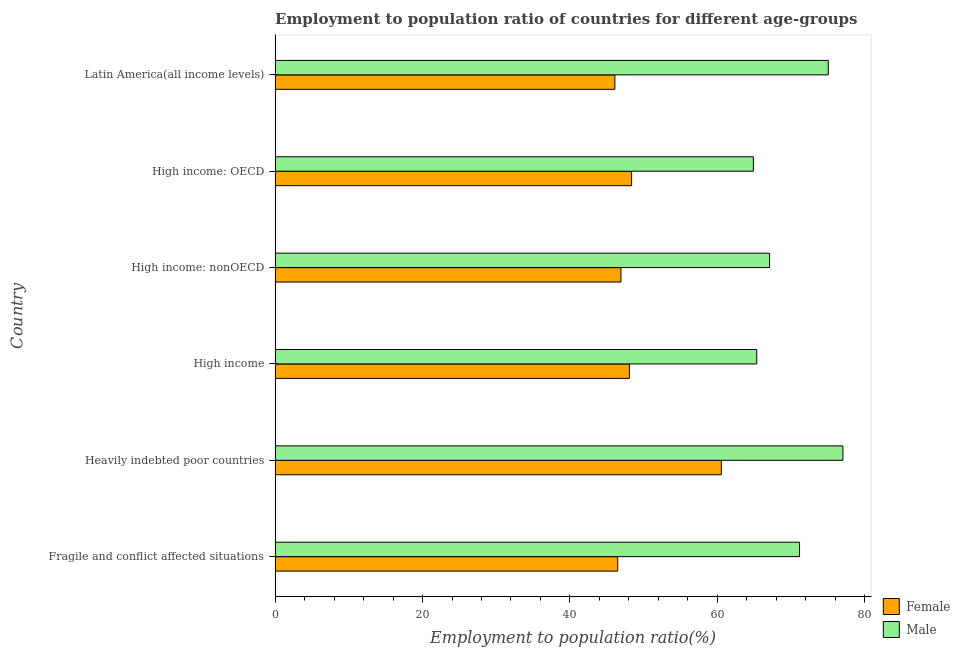How many different coloured bars are there?
Your answer should be very brief. 2. How many groups of bars are there?
Offer a very short reply. 6. Are the number of bars per tick equal to the number of legend labels?
Ensure brevity in your answer.  Yes. Are the number of bars on each tick of the Y-axis equal?
Make the answer very short. Yes. How many bars are there on the 4th tick from the top?
Provide a short and direct response. 2. What is the label of the 5th group of bars from the top?
Offer a terse response. Heavily indebted poor countries. What is the employment to population ratio(male) in Heavily indebted poor countries?
Your answer should be very brief. 77.03. Across all countries, what is the maximum employment to population ratio(female)?
Keep it short and to the point. 60.54. Across all countries, what is the minimum employment to population ratio(male)?
Keep it short and to the point. 64.89. In which country was the employment to population ratio(female) maximum?
Your answer should be compact. Heavily indebted poor countries. In which country was the employment to population ratio(male) minimum?
Your response must be concise. High income: OECD. What is the total employment to population ratio(female) in the graph?
Offer a very short reply. 296.46. What is the difference between the employment to population ratio(male) in High income and that in High income: OECD?
Your response must be concise. 0.45. What is the difference between the employment to population ratio(female) in High income and the employment to population ratio(male) in Latin America(all income levels)?
Offer a very short reply. -26.98. What is the average employment to population ratio(male) per country?
Your answer should be compact. 70.09. What is the difference between the employment to population ratio(male) and employment to population ratio(female) in Heavily indebted poor countries?
Keep it short and to the point. 16.49. What is the ratio of the employment to population ratio(male) in Fragile and conflict affected situations to that in High income: nonOECD?
Make the answer very short. 1.06. What is the difference between the highest and the second highest employment to population ratio(female)?
Ensure brevity in your answer.  12.17. What is the difference between the highest and the lowest employment to population ratio(female)?
Offer a terse response. 14.44. In how many countries, is the employment to population ratio(female) greater than the average employment to population ratio(female) taken over all countries?
Provide a succinct answer. 1. Is the sum of the employment to population ratio(male) in Fragile and conflict affected situations and Heavily indebted poor countries greater than the maximum employment to population ratio(female) across all countries?
Your response must be concise. Yes. What does the 1st bar from the top in Fragile and conflict affected situations represents?
Your answer should be compact. Male. How many bars are there?
Ensure brevity in your answer.  12. How many countries are there in the graph?
Ensure brevity in your answer.  6. What is the difference between two consecutive major ticks on the X-axis?
Make the answer very short. 20. Are the values on the major ticks of X-axis written in scientific E-notation?
Keep it short and to the point. No. Does the graph contain grids?
Your answer should be compact. No. Where does the legend appear in the graph?
Keep it short and to the point. Bottom right. How are the legend labels stacked?
Your answer should be very brief. Vertical. What is the title of the graph?
Keep it short and to the point. Employment to population ratio of countries for different age-groups. Does "Age 15+" appear as one of the legend labels in the graph?
Your answer should be very brief. No. What is the label or title of the X-axis?
Your answer should be very brief. Employment to population ratio(%). What is the label or title of the Y-axis?
Give a very brief answer. Country. What is the Employment to population ratio(%) in Female in Fragile and conflict affected situations?
Make the answer very short. 46.48. What is the Employment to population ratio(%) of Male in Fragile and conflict affected situations?
Your response must be concise. 71.15. What is the Employment to population ratio(%) in Female in Heavily indebted poor countries?
Give a very brief answer. 60.54. What is the Employment to population ratio(%) of Male in Heavily indebted poor countries?
Provide a short and direct response. 77.03. What is the Employment to population ratio(%) in Female in High income?
Provide a succinct answer. 48.06. What is the Employment to population ratio(%) in Male in High income?
Give a very brief answer. 65.34. What is the Employment to population ratio(%) of Female in High income: nonOECD?
Give a very brief answer. 46.92. What is the Employment to population ratio(%) of Male in High income: nonOECD?
Ensure brevity in your answer.  67.08. What is the Employment to population ratio(%) of Female in High income: OECD?
Your answer should be compact. 48.37. What is the Employment to population ratio(%) in Male in High income: OECD?
Offer a very short reply. 64.89. What is the Employment to population ratio(%) in Female in Latin America(all income levels)?
Your answer should be very brief. 46.09. What is the Employment to population ratio(%) in Male in Latin America(all income levels)?
Offer a terse response. 75.05. Across all countries, what is the maximum Employment to population ratio(%) in Female?
Your response must be concise. 60.54. Across all countries, what is the maximum Employment to population ratio(%) of Male?
Offer a very short reply. 77.03. Across all countries, what is the minimum Employment to population ratio(%) in Female?
Give a very brief answer. 46.09. Across all countries, what is the minimum Employment to population ratio(%) of Male?
Offer a very short reply. 64.89. What is the total Employment to population ratio(%) of Female in the graph?
Offer a very short reply. 296.46. What is the total Employment to population ratio(%) of Male in the graph?
Keep it short and to the point. 420.53. What is the difference between the Employment to population ratio(%) in Female in Fragile and conflict affected situations and that in Heavily indebted poor countries?
Keep it short and to the point. -14.06. What is the difference between the Employment to population ratio(%) in Male in Fragile and conflict affected situations and that in Heavily indebted poor countries?
Your answer should be compact. -5.88. What is the difference between the Employment to population ratio(%) of Female in Fragile and conflict affected situations and that in High income?
Offer a terse response. -1.58. What is the difference between the Employment to population ratio(%) of Male in Fragile and conflict affected situations and that in High income?
Make the answer very short. 5.81. What is the difference between the Employment to population ratio(%) of Female in Fragile and conflict affected situations and that in High income: nonOECD?
Offer a very short reply. -0.44. What is the difference between the Employment to population ratio(%) in Male in Fragile and conflict affected situations and that in High income: nonOECD?
Make the answer very short. 4.07. What is the difference between the Employment to population ratio(%) in Female in Fragile and conflict affected situations and that in High income: OECD?
Make the answer very short. -1.88. What is the difference between the Employment to population ratio(%) in Male in Fragile and conflict affected situations and that in High income: OECD?
Your answer should be very brief. 6.26. What is the difference between the Employment to population ratio(%) of Female in Fragile and conflict affected situations and that in Latin America(all income levels)?
Your answer should be compact. 0.39. What is the difference between the Employment to population ratio(%) in Male in Fragile and conflict affected situations and that in Latin America(all income levels)?
Your answer should be compact. -3.9. What is the difference between the Employment to population ratio(%) in Female in Heavily indebted poor countries and that in High income?
Provide a short and direct response. 12.47. What is the difference between the Employment to population ratio(%) in Male in Heavily indebted poor countries and that in High income?
Provide a succinct answer. 11.69. What is the difference between the Employment to population ratio(%) in Female in Heavily indebted poor countries and that in High income: nonOECD?
Ensure brevity in your answer.  13.62. What is the difference between the Employment to population ratio(%) in Male in Heavily indebted poor countries and that in High income: nonOECD?
Offer a very short reply. 9.95. What is the difference between the Employment to population ratio(%) in Female in Heavily indebted poor countries and that in High income: OECD?
Provide a succinct answer. 12.17. What is the difference between the Employment to population ratio(%) in Male in Heavily indebted poor countries and that in High income: OECD?
Your answer should be compact. 12.14. What is the difference between the Employment to population ratio(%) in Female in Heavily indebted poor countries and that in Latin America(all income levels)?
Provide a succinct answer. 14.44. What is the difference between the Employment to population ratio(%) of Male in Heavily indebted poor countries and that in Latin America(all income levels)?
Ensure brevity in your answer.  1.98. What is the difference between the Employment to population ratio(%) of Female in High income and that in High income: nonOECD?
Make the answer very short. 1.15. What is the difference between the Employment to population ratio(%) of Male in High income and that in High income: nonOECD?
Provide a short and direct response. -1.74. What is the difference between the Employment to population ratio(%) in Female in High income and that in High income: OECD?
Your answer should be compact. -0.3. What is the difference between the Employment to population ratio(%) in Male in High income and that in High income: OECD?
Ensure brevity in your answer.  0.45. What is the difference between the Employment to population ratio(%) of Female in High income and that in Latin America(all income levels)?
Offer a very short reply. 1.97. What is the difference between the Employment to population ratio(%) of Male in High income and that in Latin America(all income levels)?
Provide a succinct answer. -9.71. What is the difference between the Employment to population ratio(%) in Female in High income: nonOECD and that in High income: OECD?
Make the answer very short. -1.45. What is the difference between the Employment to population ratio(%) of Male in High income: nonOECD and that in High income: OECD?
Offer a very short reply. 2.19. What is the difference between the Employment to population ratio(%) in Female in High income: nonOECD and that in Latin America(all income levels)?
Keep it short and to the point. 0.82. What is the difference between the Employment to population ratio(%) in Male in High income: nonOECD and that in Latin America(all income levels)?
Your answer should be compact. -7.97. What is the difference between the Employment to population ratio(%) of Female in High income: OECD and that in Latin America(all income levels)?
Give a very brief answer. 2.27. What is the difference between the Employment to population ratio(%) in Male in High income: OECD and that in Latin America(all income levels)?
Your answer should be compact. -10.16. What is the difference between the Employment to population ratio(%) of Female in Fragile and conflict affected situations and the Employment to population ratio(%) of Male in Heavily indebted poor countries?
Your answer should be very brief. -30.55. What is the difference between the Employment to population ratio(%) in Female in Fragile and conflict affected situations and the Employment to population ratio(%) in Male in High income?
Your answer should be compact. -18.86. What is the difference between the Employment to population ratio(%) of Female in Fragile and conflict affected situations and the Employment to population ratio(%) of Male in High income: nonOECD?
Ensure brevity in your answer.  -20.6. What is the difference between the Employment to population ratio(%) of Female in Fragile and conflict affected situations and the Employment to population ratio(%) of Male in High income: OECD?
Your answer should be very brief. -18.41. What is the difference between the Employment to population ratio(%) in Female in Fragile and conflict affected situations and the Employment to population ratio(%) in Male in Latin America(all income levels)?
Provide a short and direct response. -28.57. What is the difference between the Employment to population ratio(%) in Female in Heavily indebted poor countries and the Employment to population ratio(%) in Male in High income?
Ensure brevity in your answer.  -4.8. What is the difference between the Employment to population ratio(%) in Female in Heavily indebted poor countries and the Employment to population ratio(%) in Male in High income: nonOECD?
Offer a very short reply. -6.54. What is the difference between the Employment to population ratio(%) of Female in Heavily indebted poor countries and the Employment to population ratio(%) of Male in High income: OECD?
Your answer should be compact. -4.35. What is the difference between the Employment to population ratio(%) of Female in Heavily indebted poor countries and the Employment to population ratio(%) of Male in Latin America(all income levels)?
Make the answer very short. -14.51. What is the difference between the Employment to population ratio(%) in Female in High income and the Employment to population ratio(%) in Male in High income: nonOECD?
Ensure brevity in your answer.  -19.01. What is the difference between the Employment to population ratio(%) in Female in High income and the Employment to population ratio(%) in Male in High income: OECD?
Ensure brevity in your answer.  -16.82. What is the difference between the Employment to population ratio(%) in Female in High income and the Employment to population ratio(%) in Male in Latin America(all income levels)?
Provide a short and direct response. -26.98. What is the difference between the Employment to population ratio(%) of Female in High income: nonOECD and the Employment to population ratio(%) of Male in High income: OECD?
Your response must be concise. -17.97. What is the difference between the Employment to population ratio(%) in Female in High income: nonOECD and the Employment to population ratio(%) in Male in Latin America(all income levels)?
Your answer should be compact. -28.13. What is the difference between the Employment to population ratio(%) in Female in High income: OECD and the Employment to population ratio(%) in Male in Latin America(all income levels)?
Your answer should be compact. -26.68. What is the average Employment to population ratio(%) of Female per country?
Your response must be concise. 49.41. What is the average Employment to population ratio(%) of Male per country?
Give a very brief answer. 70.09. What is the difference between the Employment to population ratio(%) of Female and Employment to population ratio(%) of Male in Fragile and conflict affected situations?
Offer a terse response. -24.66. What is the difference between the Employment to population ratio(%) of Female and Employment to population ratio(%) of Male in Heavily indebted poor countries?
Ensure brevity in your answer.  -16.49. What is the difference between the Employment to population ratio(%) in Female and Employment to population ratio(%) in Male in High income?
Ensure brevity in your answer.  -17.28. What is the difference between the Employment to population ratio(%) in Female and Employment to population ratio(%) in Male in High income: nonOECD?
Offer a terse response. -20.16. What is the difference between the Employment to population ratio(%) in Female and Employment to population ratio(%) in Male in High income: OECD?
Provide a succinct answer. -16.52. What is the difference between the Employment to population ratio(%) in Female and Employment to population ratio(%) in Male in Latin America(all income levels)?
Offer a very short reply. -28.95. What is the ratio of the Employment to population ratio(%) of Female in Fragile and conflict affected situations to that in Heavily indebted poor countries?
Ensure brevity in your answer.  0.77. What is the ratio of the Employment to population ratio(%) in Male in Fragile and conflict affected situations to that in Heavily indebted poor countries?
Your response must be concise. 0.92. What is the ratio of the Employment to population ratio(%) in Female in Fragile and conflict affected situations to that in High income?
Offer a terse response. 0.97. What is the ratio of the Employment to population ratio(%) of Male in Fragile and conflict affected situations to that in High income?
Ensure brevity in your answer.  1.09. What is the ratio of the Employment to population ratio(%) in Male in Fragile and conflict affected situations to that in High income: nonOECD?
Offer a terse response. 1.06. What is the ratio of the Employment to population ratio(%) in Female in Fragile and conflict affected situations to that in High income: OECD?
Your answer should be very brief. 0.96. What is the ratio of the Employment to population ratio(%) in Male in Fragile and conflict affected situations to that in High income: OECD?
Your answer should be compact. 1.1. What is the ratio of the Employment to population ratio(%) of Female in Fragile and conflict affected situations to that in Latin America(all income levels)?
Your response must be concise. 1.01. What is the ratio of the Employment to population ratio(%) in Male in Fragile and conflict affected situations to that in Latin America(all income levels)?
Keep it short and to the point. 0.95. What is the ratio of the Employment to population ratio(%) in Female in Heavily indebted poor countries to that in High income?
Make the answer very short. 1.26. What is the ratio of the Employment to population ratio(%) in Male in Heavily indebted poor countries to that in High income?
Give a very brief answer. 1.18. What is the ratio of the Employment to population ratio(%) of Female in Heavily indebted poor countries to that in High income: nonOECD?
Provide a short and direct response. 1.29. What is the ratio of the Employment to population ratio(%) in Male in Heavily indebted poor countries to that in High income: nonOECD?
Make the answer very short. 1.15. What is the ratio of the Employment to population ratio(%) in Female in Heavily indebted poor countries to that in High income: OECD?
Provide a short and direct response. 1.25. What is the ratio of the Employment to population ratio(%) of Male in Heavily indebted poor countries to that in High income: OECD?
Ensure brevity in your answer.  1.19. What is the ratio of the Employment to population ratio(%) in Female in Heavily indebted poor countries to that in Latin America(all income levels)?
Provide a succinct answer. 1.31. What is the ratio of the Employment to population ratio(%) of Male in Heavily indebted poor countries to that in Latin America(all income levels)?
Offer a terse response. 1.03. What is the ratio of the Employment to population ratio(%) in Female in High income to that in High income: nonOECD?
Provide a short and direct response. 1.02. What is the ratio of the Employment to population ratio(%) of Male in High income to that in High income: nonOECD?
Your answer should be very brief. 0.97. What is the ratio of the Employment to population ratio(%) of Male in High income to that in High income: OECD?
Make the answer very short. 1.01. What is the ratio of the Employment to population ratio(%) in Female in High income to that in Latin America(all income levels)?
Keep it short and to the point. 1.04. What is the ratio of the Employment to population ratio(%) of Male in High income to that in Latin America(all income levels)?
Offer a terse response. 0.87. What is the ratio of the Employment to population ratio(%) in Female in High income: nonOECD to that in High income: OECD?
Your answer should be very brief. 0.97. What is the ratio of the Employment to population ratio(%) of Male in High income: nonOECD to that in High income: OECD?
Give a very brief answer. 1.03. What is the ratio of the Employment to population ratio(%) of Female in High income: nonOECD to that in Latin America(all income levels)?
Provide a short and direct response. 1.02. What is the ratio of the Employment to population ratio(%) of Male in High income: nonOECD to that in Latin America(all income levels)?
Make the answer very short. 0.89. What is the ratio of the Employment to population ratio(%) in Female in High income: OECD to that in Latin America(all income levels)?
Offer a very short reply. 1.05. What is the ratio of the Employment to population ratio(%) of Male in High income: OECD to that in Latin America(all income levels)?
Offer a terse response. 0.86. What is the difference between the highest and the second highest Employment to population ratio(%) in Female?
Keep it short and to the point. 12.17. What is the difference between the highest and the second highest Employment to population ratio(%) in Male?
Your answer should be compact. 1.98. What is the difference between the highest and the lowest Employment to population ratio(%) of Female?
Your response must be concise. 14.44. What is the difference between the highest and the lowest Employment to population ratio(%) of Male?
Keep it short and to the point. 12.14. 